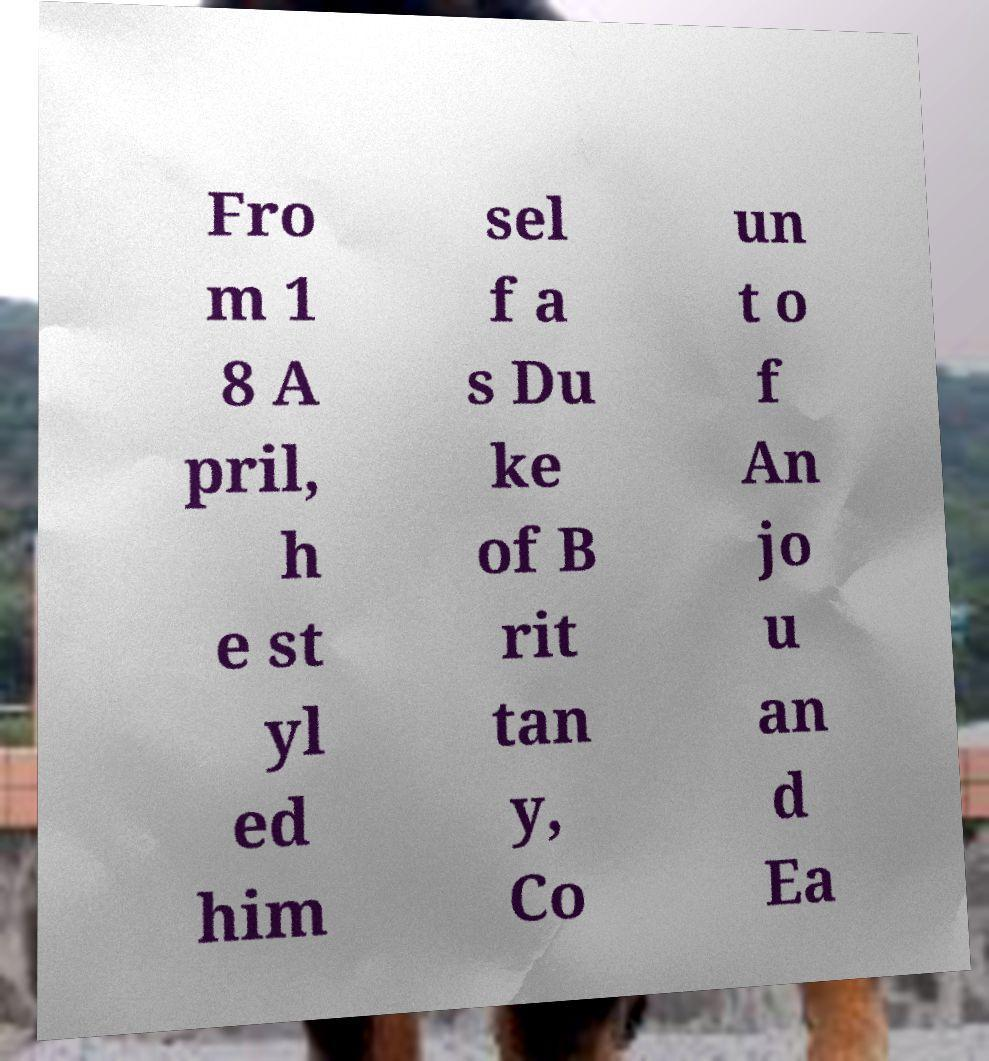Could you extract and type out the text from this image? Fro m 1 8 A pril, h e st yl ed him sel f a s Du ke of B rit tan y, Co un t o f An jo u an d Ea 